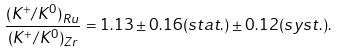Convert formula to latex. <formula><loc_0><loc_0><loc_500><loc_500>\frac { ( K ^ { + } / K ^ { 0 } ) _ { R u } } { ( K ^ { + } / K ^ { 0 } ) _ { Z r } } = 1 . 1 3 \pm 0 . 1 6 ( s t a t . ) \pm 0 . 1 2 ( s y s t . ) .</formula> 